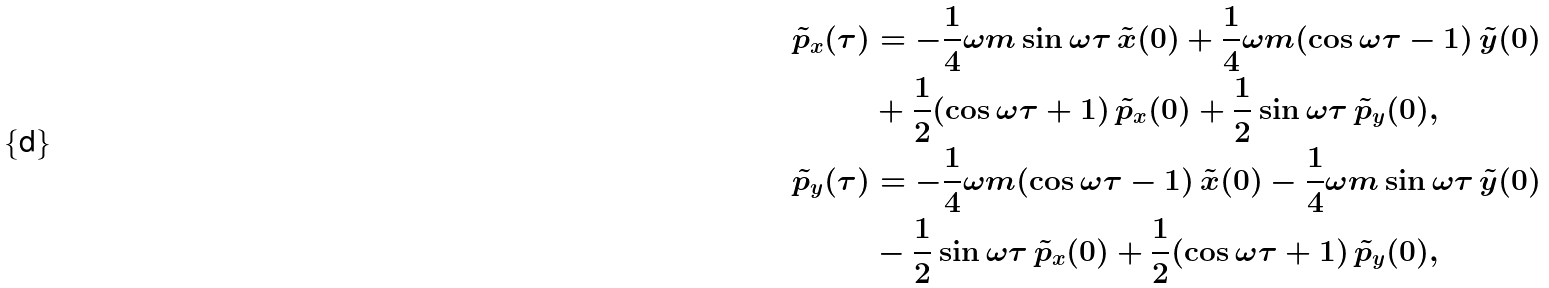Convert formula to latex. <formula><loc_0><loc_0><loc_500><loc_500>\tilde { p } _ { x } ( \tau ) & = - \frac { 1 } { 4 } \omega m \sin \omega \tau \, \tilde { x } ( 0 ) + \frac { 1 } { 4 } \omega m ( \cos \omega \tau - 1 ) \, \tilde { y } ( 0 ) \\ & + \frac { 1 } { 2 } ( \cos \omega \tau + 1 ) \, \tilde { p } _ { x } ( 0 ) + \frac { 1 } { 2 } \sin \omega \tau \, \tilde { p } _ { y } ( 0 ) , \\ \tilde { p } _ { y } ( \tau ) & = - \frac { 1 } { 4 } \omega m ( \cos \omega \tau - 1 ) \, \tilde { x } ( 0 ) - \frac { 1 } { 4 } \omega m \sin \omega \tau \, \tilde { y } ( 0 ) \\ & - \frac { 1 } { 2 } \sin \omega \tau \, \tilde { p } _ { x } ( 0 ) + \frac { 1 } { 2 } ( \cos \omega \tau + 1 ) \, \tilde { p } _ { y } ( 0 ) , \\</formula> 